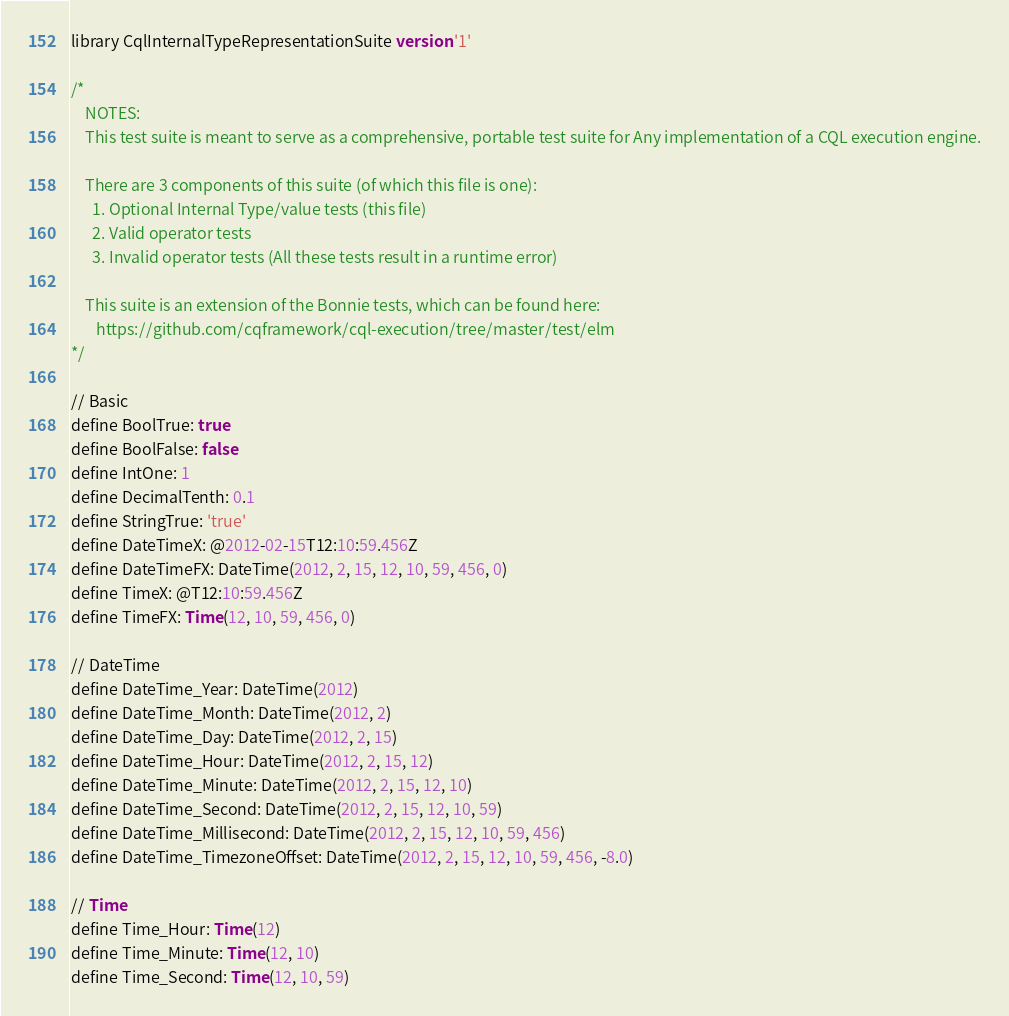<code> <loc_0><loc_0><loc_500><loc_500><_SQL_>library CqlInternalTypeRepresentationSuite version '1'

/*
    NOTES:
    This test suite is meant to serve as a comprehensive, portable test suite for Any implementation of a CQL execution engine.

    There are 3 components of this suite (of which this file is one):
      1. Optional Internal Type/value tests (this file)
      2. Valid operator tests
      3. Invalid operator tests (All these tests result in a runtime error)

    This suite is an extension of the Bonnie tests, which can be found here:
       https://github.com/cqframework/cql-execution/tree/master/test/elm
*/

// Basic
define BoolTrue: true
define BoolFalse: false
define IntOne: 1
define DecimalTenth: 0.1
define StringTrue: 'true'
define DateTimeX: @2012-02-15T12:10:59.456Z
define DateTimeFX: DateTime(2012, 2, 15, 12, 10, 59, 456, 0)
define TimeX: @T12:10:59.456Z
define TimeFX: Time(12, 10, 59, 456, 0)

// DateTime
define DateTime_Year: DateTime(2012)
define DateTime_Month: DateTime(2012, 2)
define DateTime_Day: DateTime(2012, 2, 15)
define DateTime_Hour: DateTime(2012, 2, 15, 12)
define DateTime_Minute: DateTime(2012, 2, 15, 12, 10)
define DateTime_Second: DateTime(2012, 2, 15, 12, 10, 59)
define DateTime_Millisecond: DateTime(2012, 2, 15, 12, 10, 59, 456)
define DateTime_TimezoneOffset: DateTime(2012, 2, 15, 12, 10, 59, 456, -8.0)

// Time
define Time_Hour: Time(12)
define Time_Minute: Time(12, 10)
define Time_Second: Time(12, 10, 59)</code> 